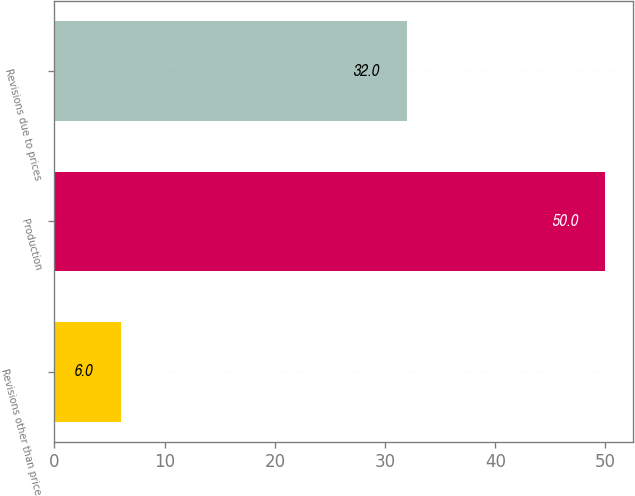<chart> <loc_0><loc_0><loc_500><loc_500><bar_chart><fcel>Revisions other than price<fcel>Production<fcel>Revisions due to prices<nl><fcel>6<fcel>50<fcel>32<nl></chart> 